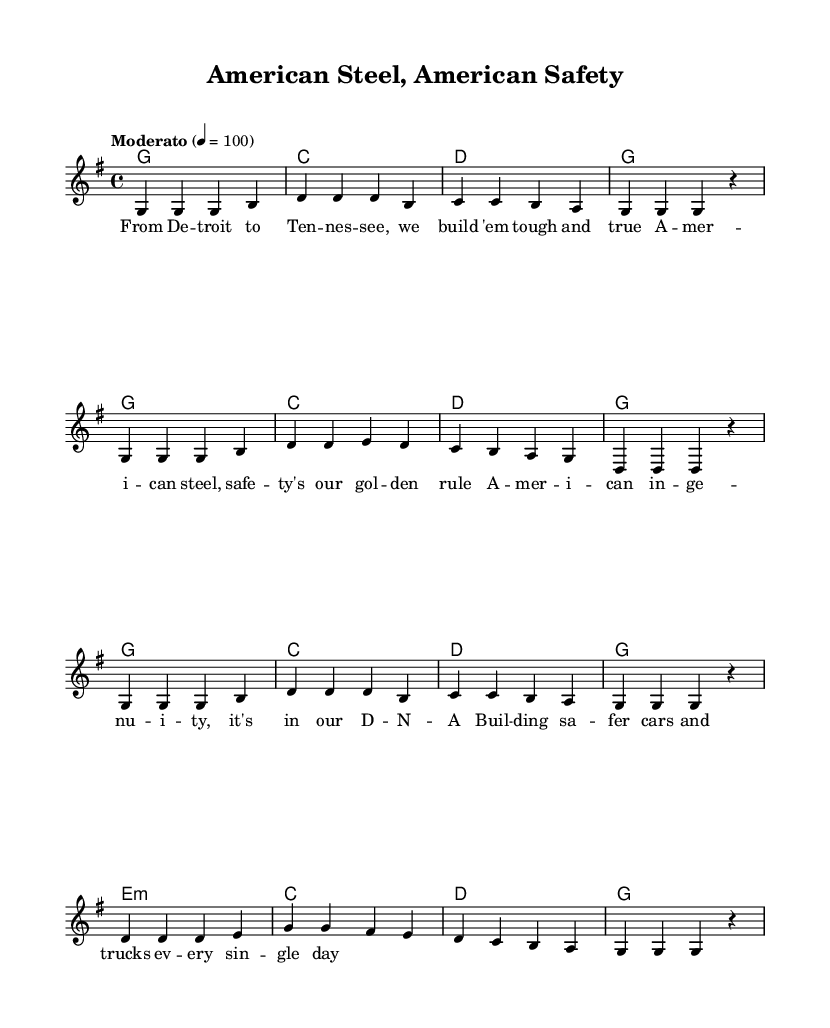What is the key signature of this music? The key signature is G major, which has one sharp (F#). We can determine this by examining the key signature notation at the beginning of the score.
Answer: G major What is the time signature of this music? The time signature is 4/4, indicated at the beginning of the score. This tells us that there are four beats in each measure, and the quarter note receives one beat.
Answer: 4/4 What is the tempo marking for this piece? The tempo marking states "Moderato" with a metronome marking of 4 = 100, meaning the piece should be performed at a moderate speed of 100 beats per minute. This is determined by looking at the tempo indication at the start of the piece.
Answer: Moderato How many measures are in the Chorus section? There are 8 measures in the Chorus section, which can be counted by looking at the notated music for that specific section.
Answer: 8 What is the first chord listed in the harmonies? The first chord in the harmonies section is G major, which can be found at the beginning of the chord mode section, indicating the harmonic support for the melody.
Answer: G What lyrical theme does the verse focus on? The lyrics of the verse focus on American manufacturing and safety innovation, as indicated in the text provided below the melody. This can be identified by reading through the lyrics and identifying key phrases that highlight these themes.
Answer: American manufacturing Which section of the music contains a minor chord? The chord e:m corresponds to a minor chord in the Chorus, which is indicated specifically in the chord mode section after the G major transition.
Answer: e:m 